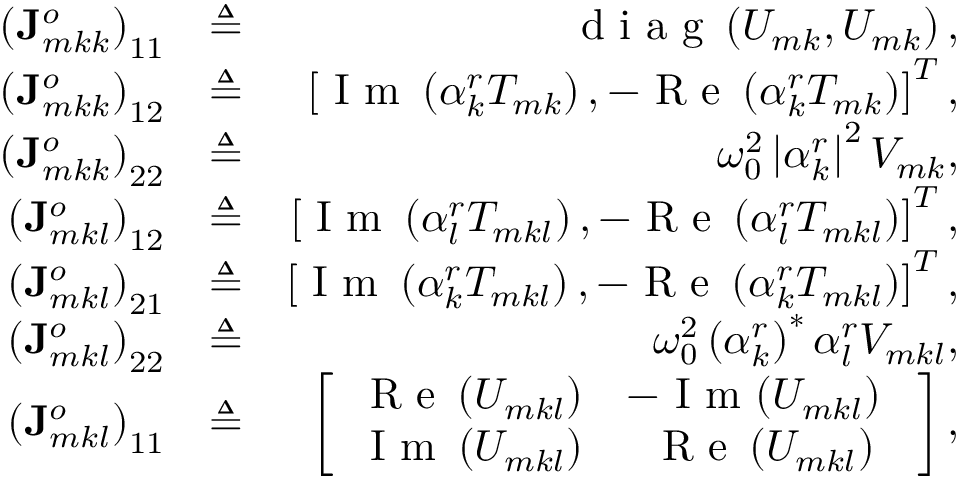<formula> <loc_0><loc_0><loc_500><loc_500>\begin{array} { r l r } { \left ( J _ { m k k } ^ { o } \right ) _ { 1 1 } } & { \triangle q } & { d i a g \left ( U _ { m k } , U _ { m k } \right ) , } \\ { \left ( J _ { m k k } ^ { o } \right ) _ { 1 2 } } & { \triangle q } & { \left [ I m \left ( \alpha _ { k } ^ { r } T _ { m k } \right ) , - R e \left ( \alpha _ { k } ^ { r } T _ { m k } \right ) \right ] ^ { T } , } \\ { \left ( J _ { m k k } ^ { o } \right ) _ { 2 2 } } & { \triangle q } & { \omega _ { 0 } ^ { 2 } \left | \alpha _ { k } ^ { r } \right | ^ { 2 } V _ { m k } , } \\ { \left ( J _ { m k l } ^ { o } \right ) _ { 1 2 } } & { \triangle q } & { \left [ I m \left ( \alpha _ { l } ^ { r } T _ { m k l } \right ) , - R e \left ( \alpha _ { l } ^ { r } T _ { m k l } \right ) \right ] ^ { T } , } \\ { \left ( J _ { m k l } ^ { o } \right ) _ { 2 1 } } & { \triangle q } & { \left [ I m \left ( \alpha _ { k } ^ { r } T _ { m k l } \right ) , - R e \left ( \alpha _ { k } ^ { r } T _ { m k l } \right ) \right ] ^ { T } , } \\ { \left ( J _ { m k l } ^ { o } \right ) _ { 2 2 } } & { \triangle q } & { \omega _ { 0 } ^ { 2 } \left ( \alpha _ { k } ^ { r } \right ) ^ { * } \alpha _ { l } ^ { r } V _ { m k l } , } \\ { \left ( J _ { m k l } ^ { o } \right ) _ { 1 1 } } & { \triangle q } & { \left [ \begin{array} { c c } { R e \left ( U _ { m k l } \right ) } & { - I m { \left ( U _ { m k l } \right ) } } \\ { I m \left ( U _ { m k l } \right ) } & { R e \left ( U _ { m k l } \right ) } \end{array} \right ] , } \end{array}</formula> 